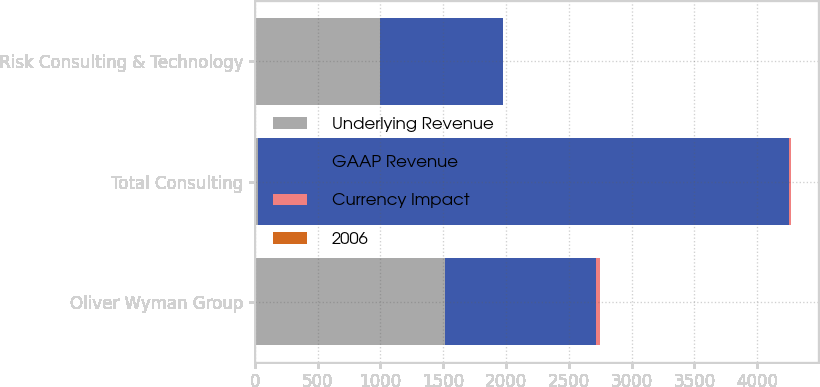<chart> <loc_0><loc_0><loc_500><loc_500><stacked_bar_chart><ecel><fcel>Oliver Wyman Group<fcel>Total Consulting<fcel>Risk Consulting & Technology<nl><fcel>Underlying Revenue<fcel>1516<fcel>26<fcel>995<nl><fcel>GAAP Revenue<fcel>1204<fcel>4225<fcel>979<nl><fcel>Currency Impact<fcel>26<fcel>16<fcel>2<nl><fcel>2006<fcel>5<fcel>5<fcel>2<nl></chart> 